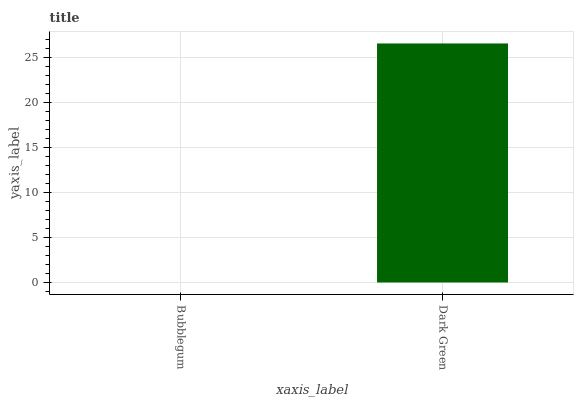Is Dark Green the minimum?
Answer yes or no. No. Is Dark Green greater than Bubblegum?
Answer yes or no. Yes. Is Bubblegum less than Dark Green?
Answer yes or no. Yes. Is Bubblegum greater than Dark Green?
Answer yes or no. No. Is Dark Green less than Bubblegum?
Answer yes or no. No. Is Dark Green the high median?
Answer yes or no. Yes. Is Bubblegum the low median?
Answer yes or no. Yes. Is Bubblegum the high median?
Answer yes or no. No. Is Dark Green the low median?
Answer yes or no. No. 